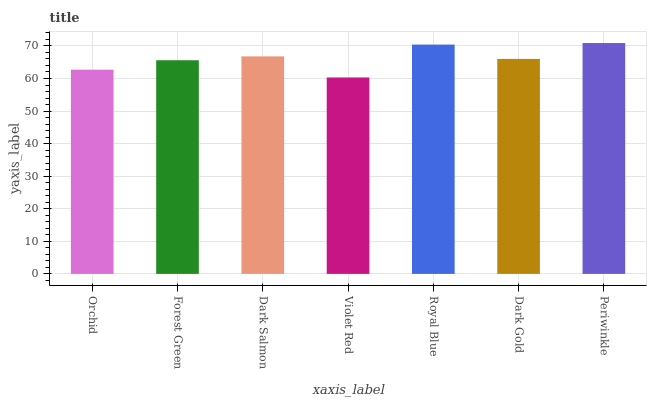Is Forest Green the minimum?
Answer yes or no. No. Is Forest Green the maximum?
Answer yes or no. No. Is Forest Green greater than Orchid?
Answer yes or no. Yes. Is Orchid less than Forest Green?
Answer yes or no. Yes. Is Orchid greater than Forest Green?
Answer yes or no. No. Is Forest Green less than Orchid?
Answer yes or no. No. Is Dark Gold the high median?
Answer yes or no. Yes. Is Dark Gold the low median?
Answer yes or no. Yes. Is Dark Salmon the high median?
Answer yes or no. No. Is Orchid the low median?
Answer yes or no. No. 